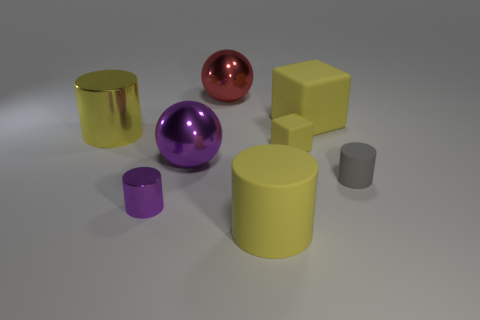What size is the metallic cylinder that is the same color as the tiny matte cube?
Offer a very short reply. Large. Do the big purple object and the small yellow rubber object have the same shape?
Your answer should be compact. No. Are there any tiny gray things of the same shape as the tiny yellow rubber object?
Make the answer very short. No. There is a purple object that is behind the tiny cylinder right of the big red ball; what is its shape?
Make the answer very short. Sphere. What is the color of the object left of the tiny purple thing?
Your response must be concise. Yellow. What size is the other yellow block that is made of the same material as the tiny yellow block?
Your answer should be very brief. Large. What size is the other gray object that is the same shape as the small metallic object?
Your response must be concise. Small. Are any shiny objects visible?
Provide a short and direct response. Yes. What number of objects are either large yellow rubber things behind the small matte cylinder or big cyan metal things?
Offer a terse response. 1. What material is the red ball that is the same size as the yellow matte cylinder?
Your answer should be very brief. Metal. 